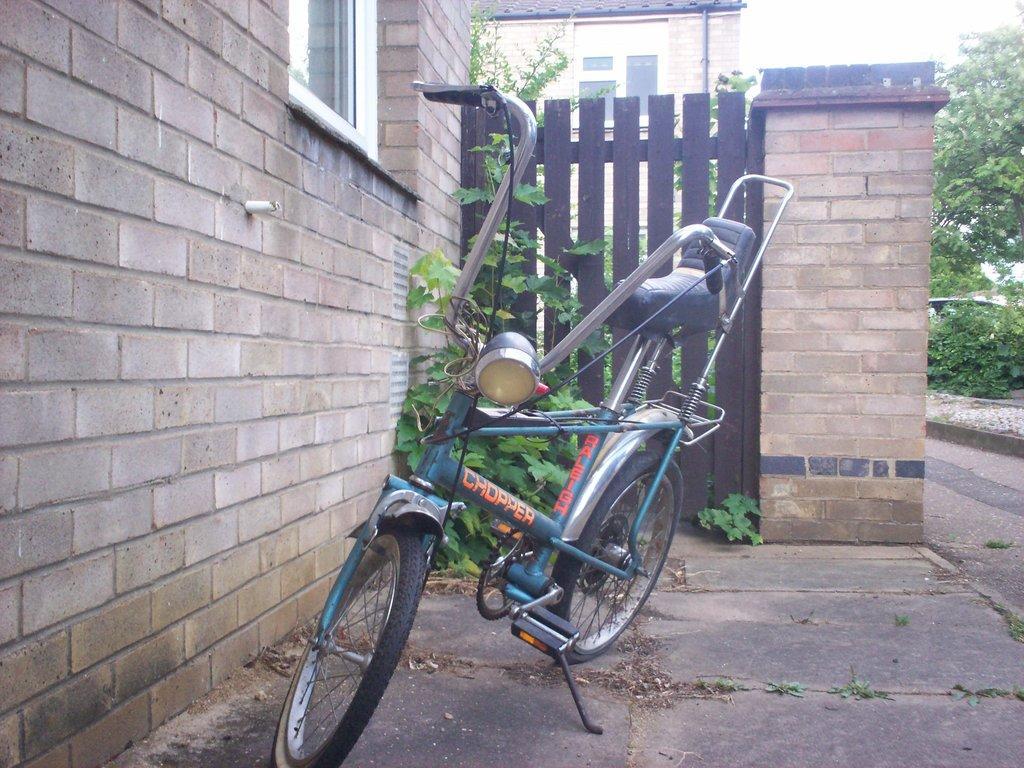Could you give a brief overview of what you see in this image? In this image I see a cycle on which there are 2 words written and I see the wall, a window, wooden fencing, plants and the path. In the background I see the trees, a building over here and I see the white sky. 